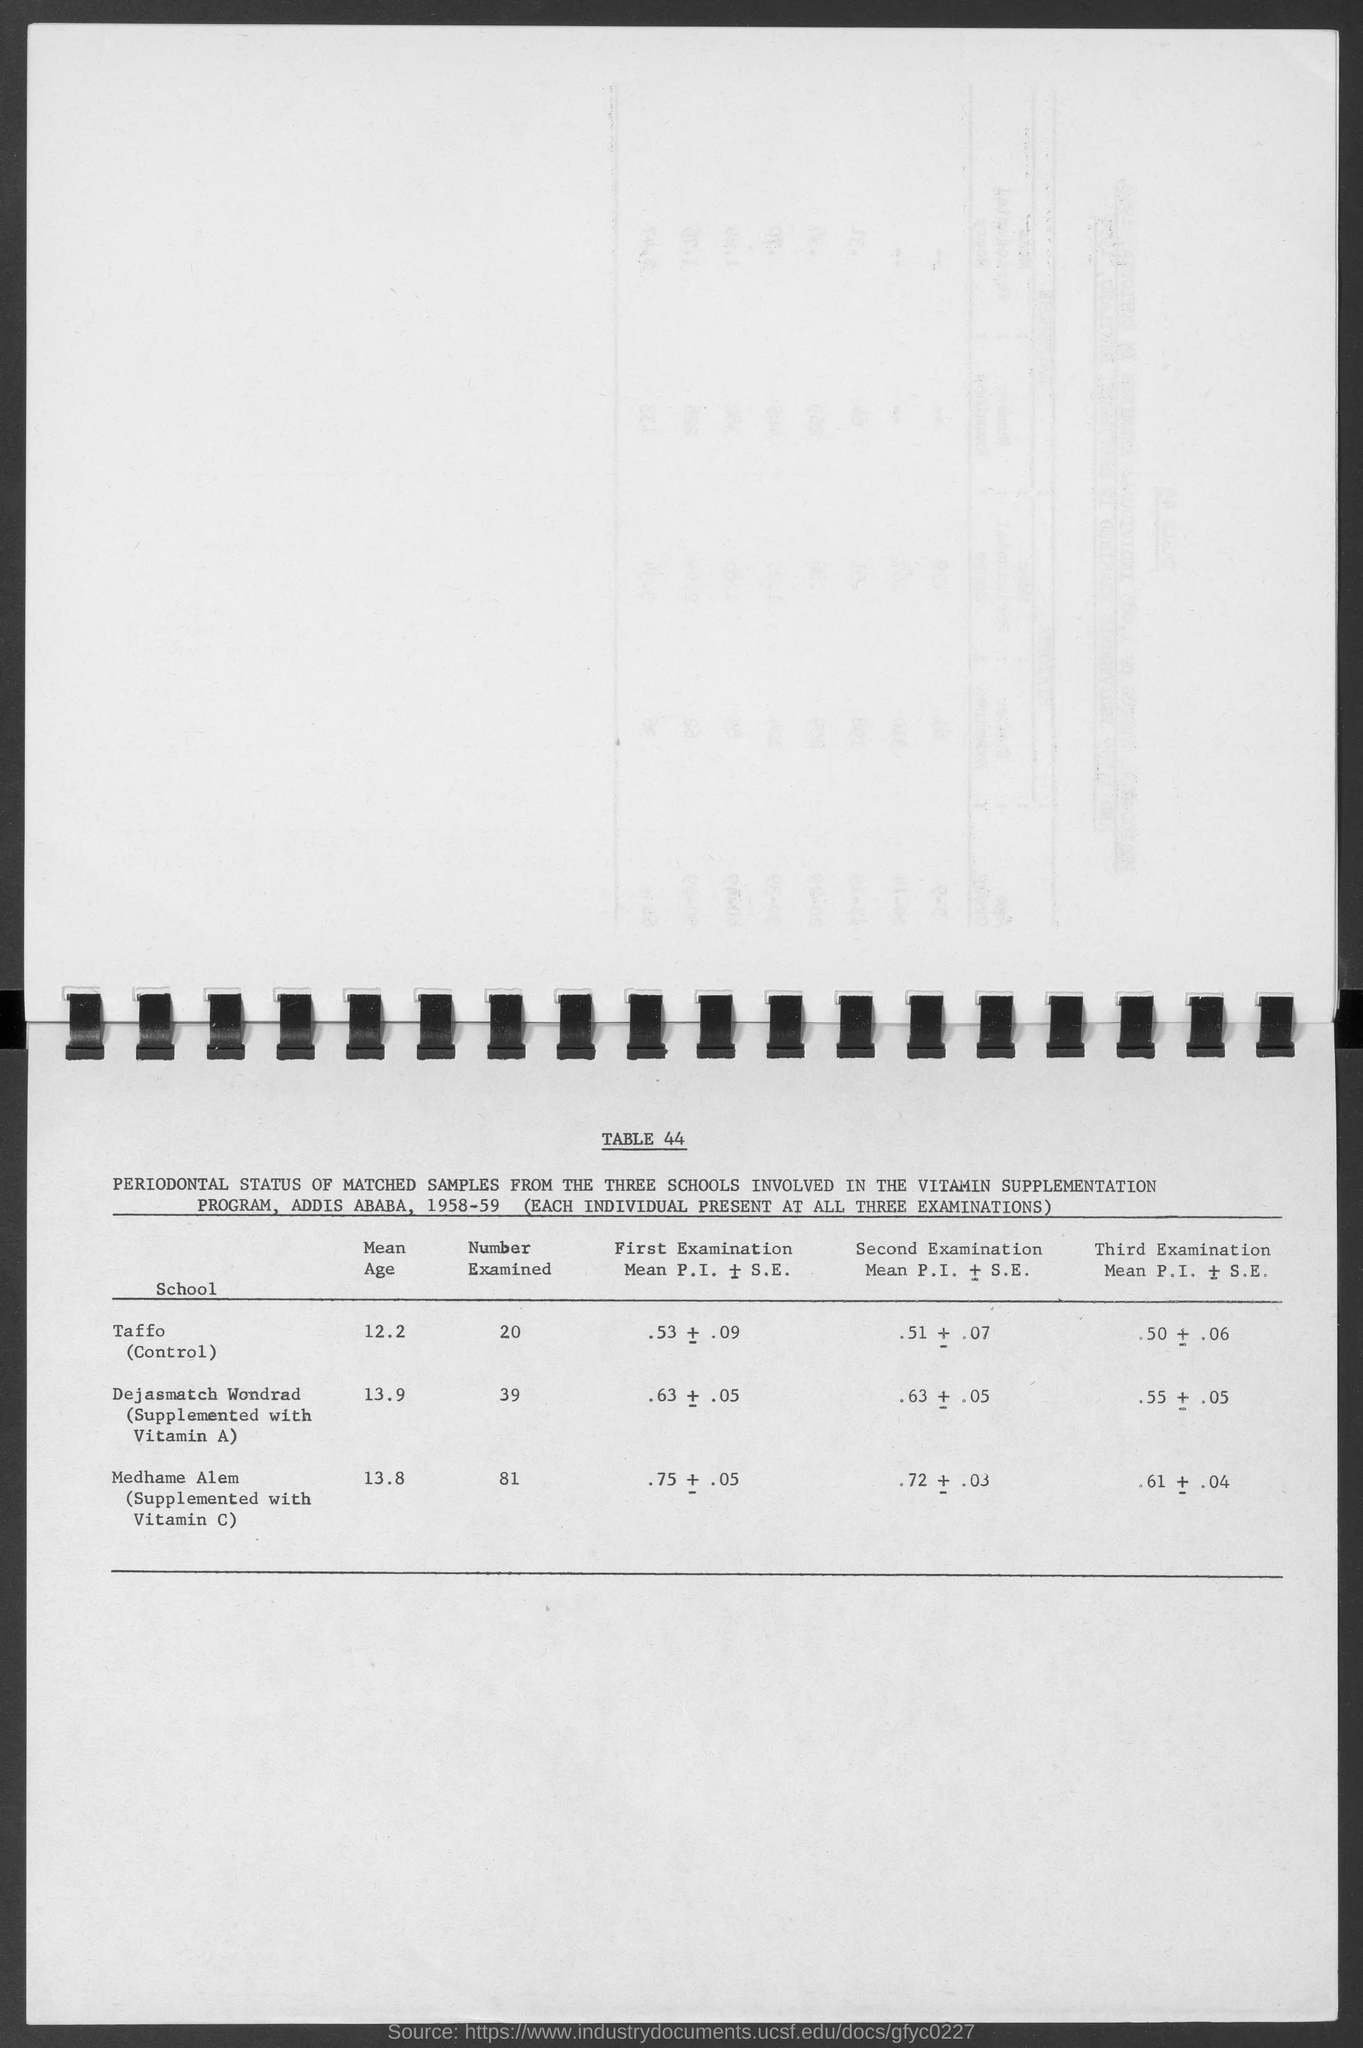Specify some key components in this picture. Three schools are participating in the Vitamin Supplementation Program. The mean age of the Taffo is 12.2 years. 